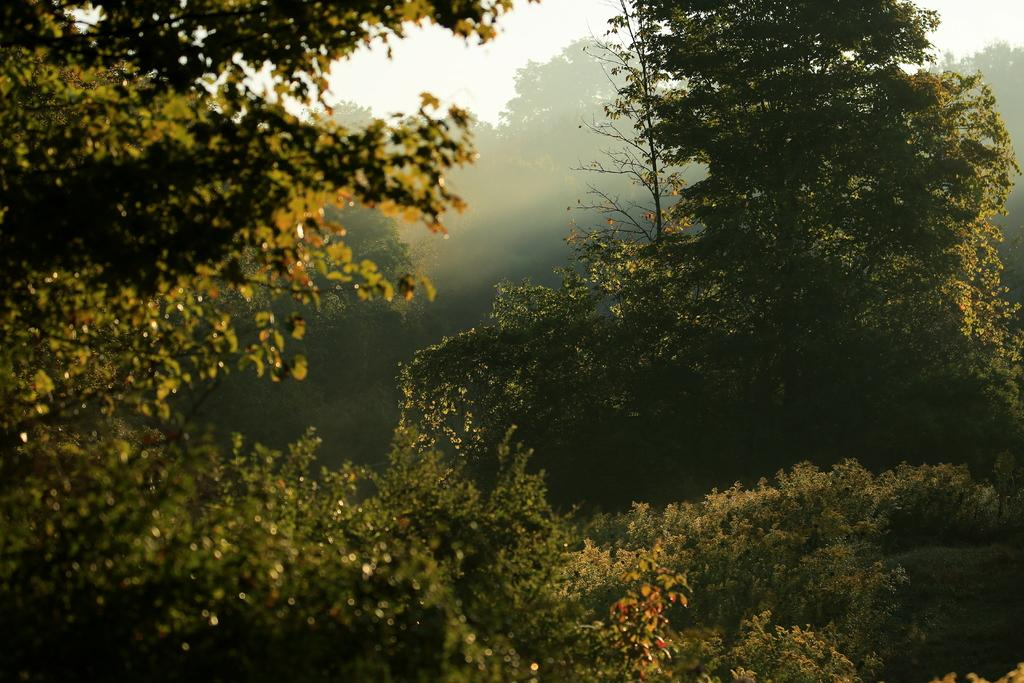What type of vegetation can be seen in the picture? There are trees in the picture. What is visible in the background of the picture? There is a clear sky visible in the background of the picture. Where is the hydrant located in the picture? There is no hydrant present in the picture. What is the aftermath of the event in the picture? There is no event or aftermath mentioned in the provided facts, as the image only features trees and a clear sky. 